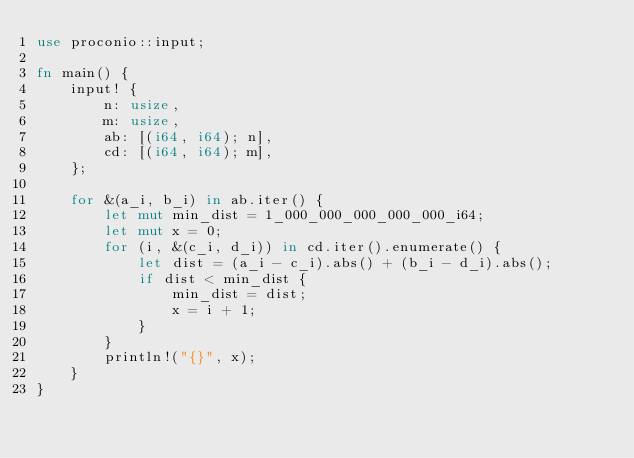Convert code to text. <code><loc_0><loc_0><loc_500><loc_500><_Rust_>use proconio::input;

fn main() {
    input! {
        n: usize,
        m: usize,
        ab: [(i64, i64); n],
        cd: [(i64, i64); m],
    };

    for &(a_i, b_i) in ab.iter() {
        let mut min_dist = 1_000_000_000_000_000_i64;
        let mut x = 0;
        for (i, &(c_i, d_i)) in cd.iter().enumerate() {
            let dist = (a_i - c_i).abs() + (b_i - d_i).abs();
            if dist < min_dist {
                min_dist = dist;
                x = i + 1;
            }
        }
        println!("{}", x);
    }
}
</code> 